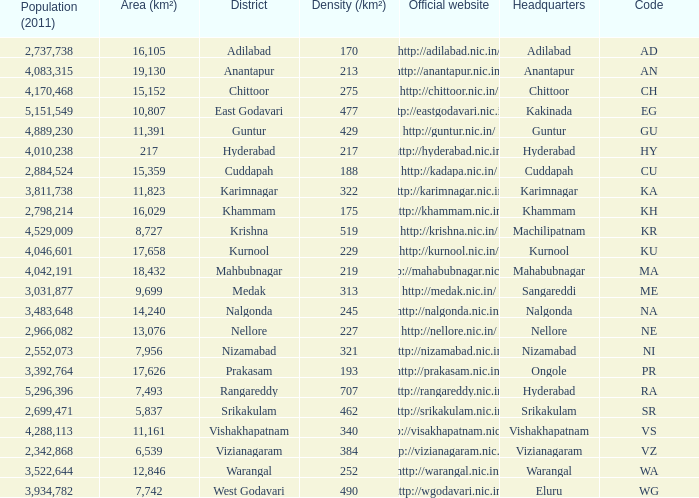What is the sum of the area values for districts having density over 462 and websites of http://krishna.nic.in/? 8727.0. 